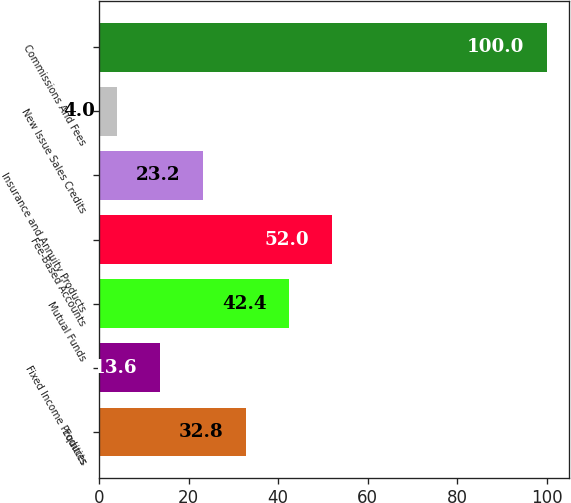<chart> <loc_0><loc_0><loc_500><loc_500><bar_chart><fcel>Equities<fcel>Fixed Income Products<fcel>Mutual Funds<fcel>Fee-Based Accounts<fcel>Insurance and Annuity Products<fcel>New Issue Sales Credits<fcel>Commissions And Fees<nl><fcel>32.8<fcel>13.6<fcel>42.4<fcel>52<fcel>23.2<fcel>4<fcel>100<nl></chart> 